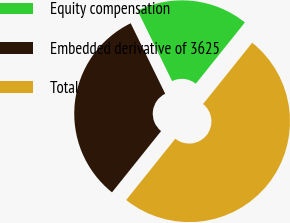<chart> <loc_0><loc_0><loc_500><loc_500><pie_chart><fcel>Equity compensation<fcel>Embedded derivative of 3625<fcel>Total<nl><fcel>18.0%<fcel>32.0%<fcel>50.0%<nl></chart> 